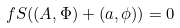Convert formula to latex. <formula><loc_0><loc_0><loc_500><loc_500>\ f S ( ( A , \Phi ) + ( a , \phi ) ) = 0</formula> 